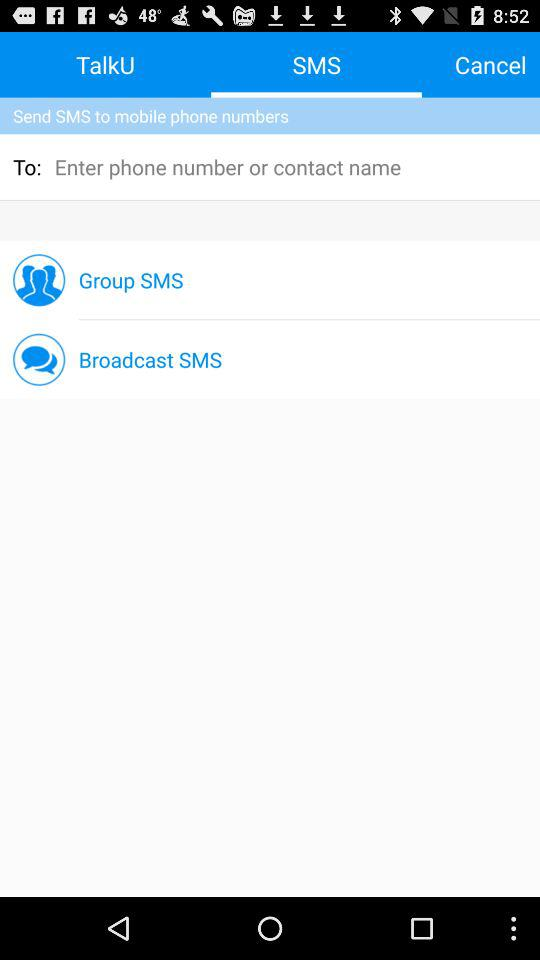Which tab is selected? The selected tab is "SMS". 